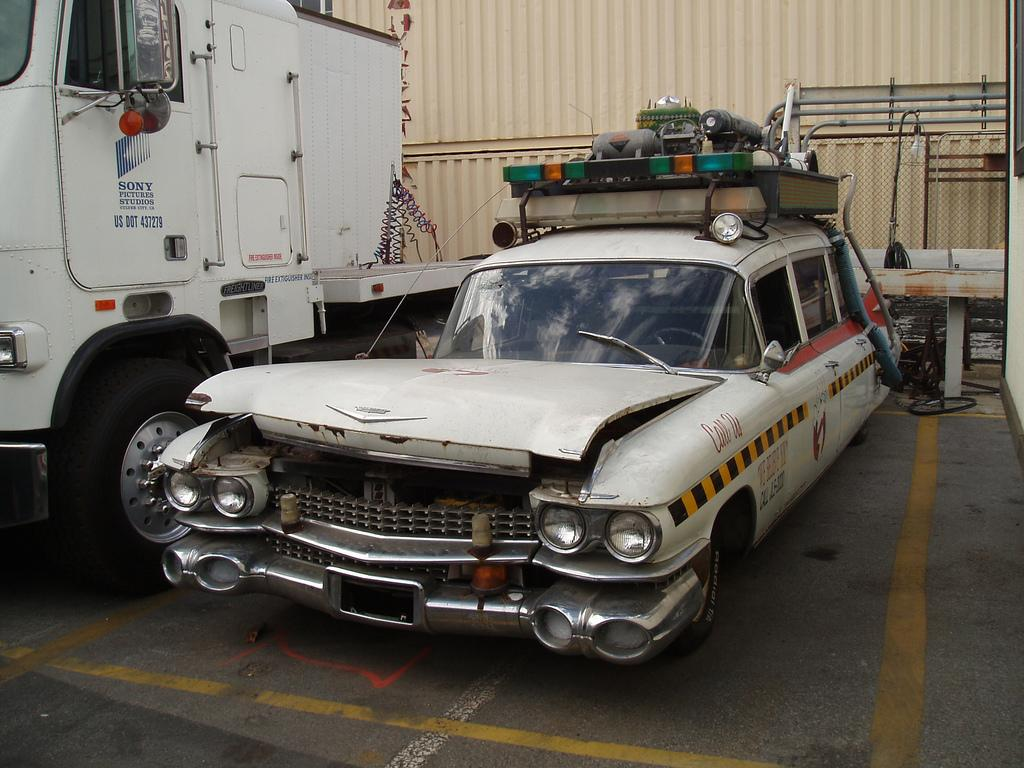What can be seen in the image? There are vehicles in the image. What is the status of the vehicles? The vehicles are parked. Are there any additional items on the vehicles? Yes, there are objects on top of a car. What can be seen in the background of the image? There is an iron container in the background of the image. What type of vegetable is being used as a memory aid in the image? There is no vegetable or memory aid present in the image. 